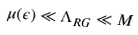Convert formula to latex. <formula><loc_0><loc_0><loc_500><loc_500>\mu ( \epsilon ) \ll \Lambda _ { R G } \ll M</formula> 